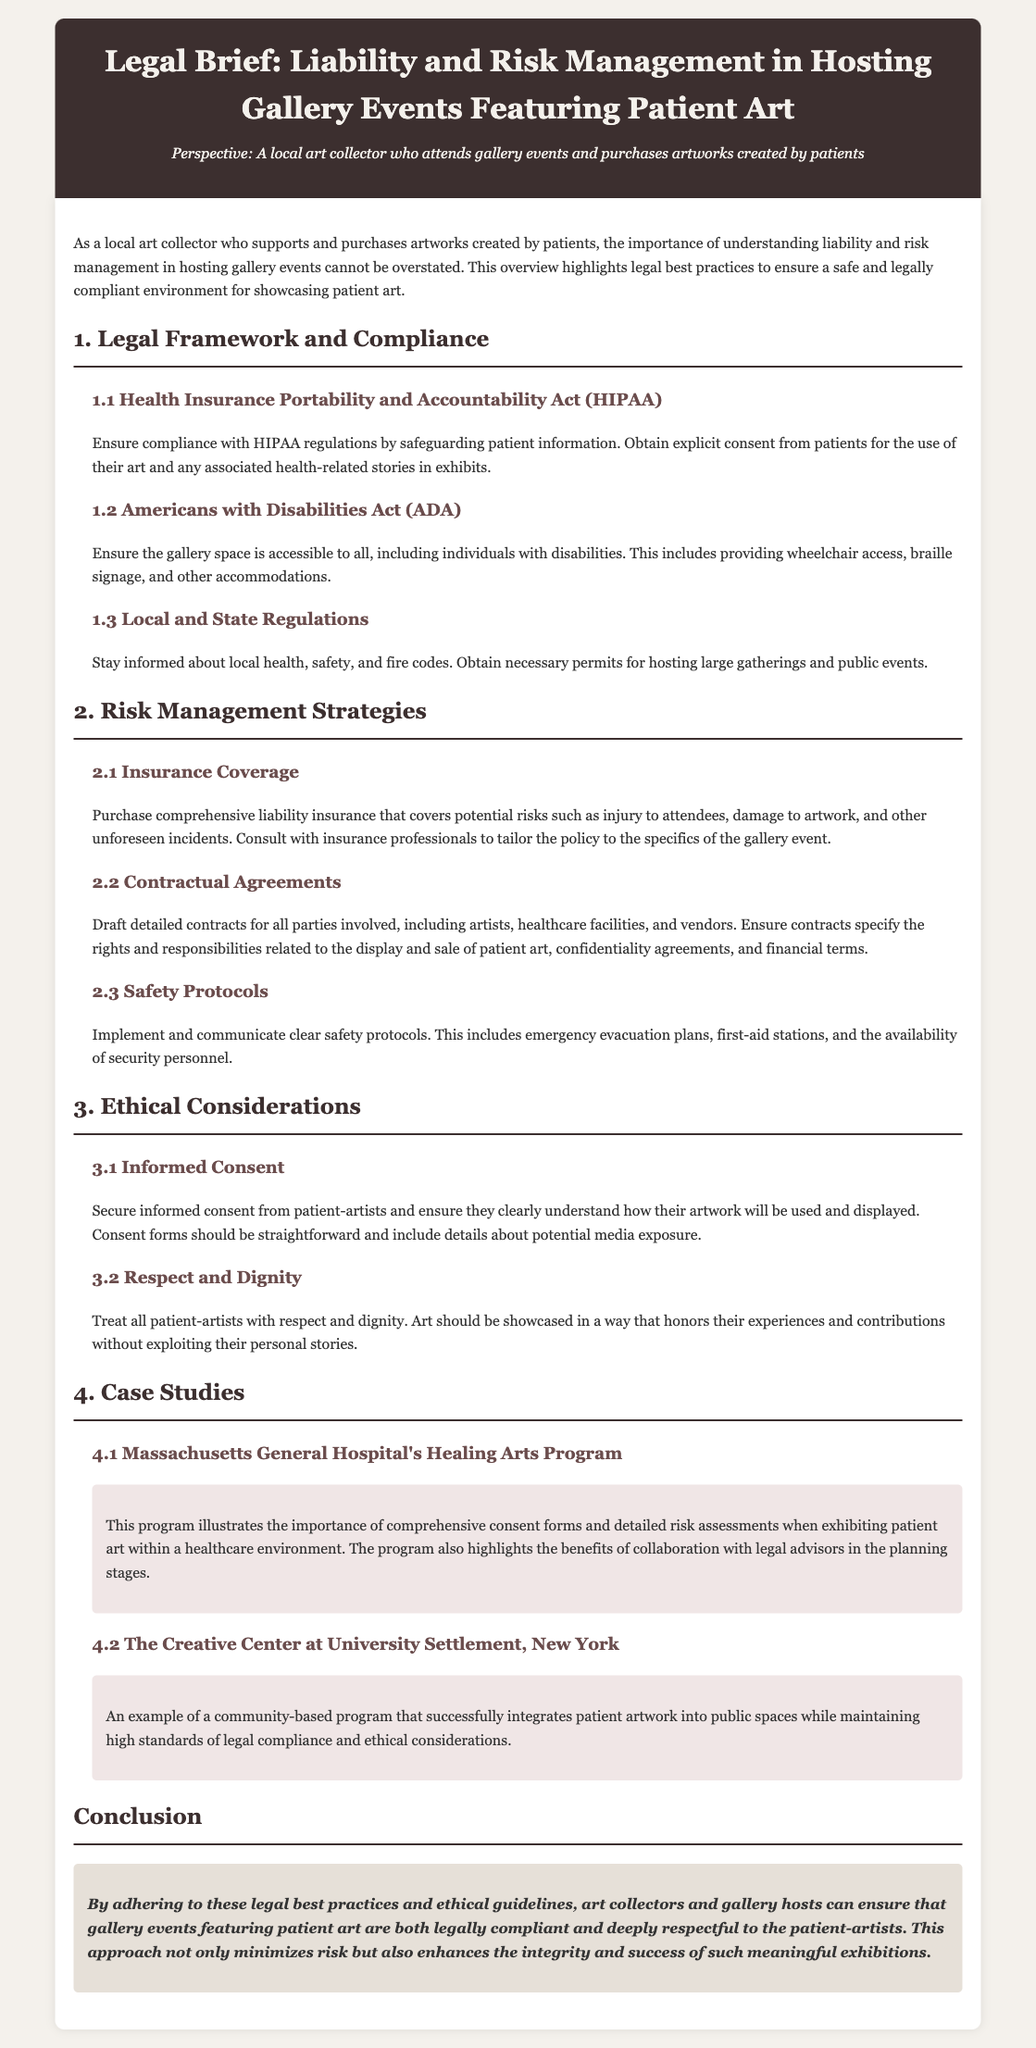What is the title of the document? The title of the document is displayed prominently at the top of the page, indicating the focus on legal aspects of gallery events.
Answer: Legal Brief: Liability and Risk Management in Hosting Gallery Events Featuring Patient Art What act must be complied with to safeguard patient information? The document mentions the necessity of complying with specific regulations related to patient information.
Answer: HIPAA What is one requirement for gallery accessibility? The document specifies a legal requirement regarding accessibility in gallery spaces.
Answer: Wheelchair access What type of insurance should be purchased for hosting events? The document discusses the importance of specific insurance coverage tailored to the event's risks.
Answer: Comprehensive liability insurance What are contracts supposed to specify? The legal brief outlines the purpose of contractual agreements in relation to the artwork and other parties involved.
Answer: Rights and responsibilities Which program is highlighted as a case study from Massachusetts? The case studies in the document provide real-world examples pertinent to patient art exhibits.
Answer: Massachusetts General Hospital's Healing Arts Program What is a key consideration for treating patient-artists? The document emphasizes the importance of an attitude towards patient-artists in gallery events.
Answer: Respect and dignity What should informed consent forms include? The document defines what elements should be present in informed consent for patient-artists.
Answer: Potential media exposure 